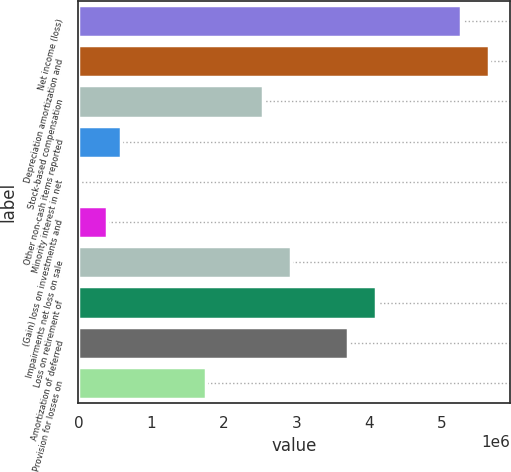Convert chart. <chart><loc_0><loc_0><loc_500><loc_500><bar_chart><fcel>Net income (loss)<fcel>Depreciation amortization and<fcel>Stock-based compensation<fcel>Other non-cash items reported<fcel>Minority interest in net<fcel>(Gain) loss on investments and<fcel>Impairments net loss on sale<fcel>Loss on retirement of<fcel>Amortization of deferred<fcel>Provision for losses on<nl><fcel>5.26252e+06<fcel>5.6523e+06<fcel>2.5341e+06<fcel>585236<fcel>575<fcel>390349<fcel>2.92388e+06<fcel>4.0932e+06<fcel>3.70343e+06<fcel>1.75456e+06<nl></chart> 